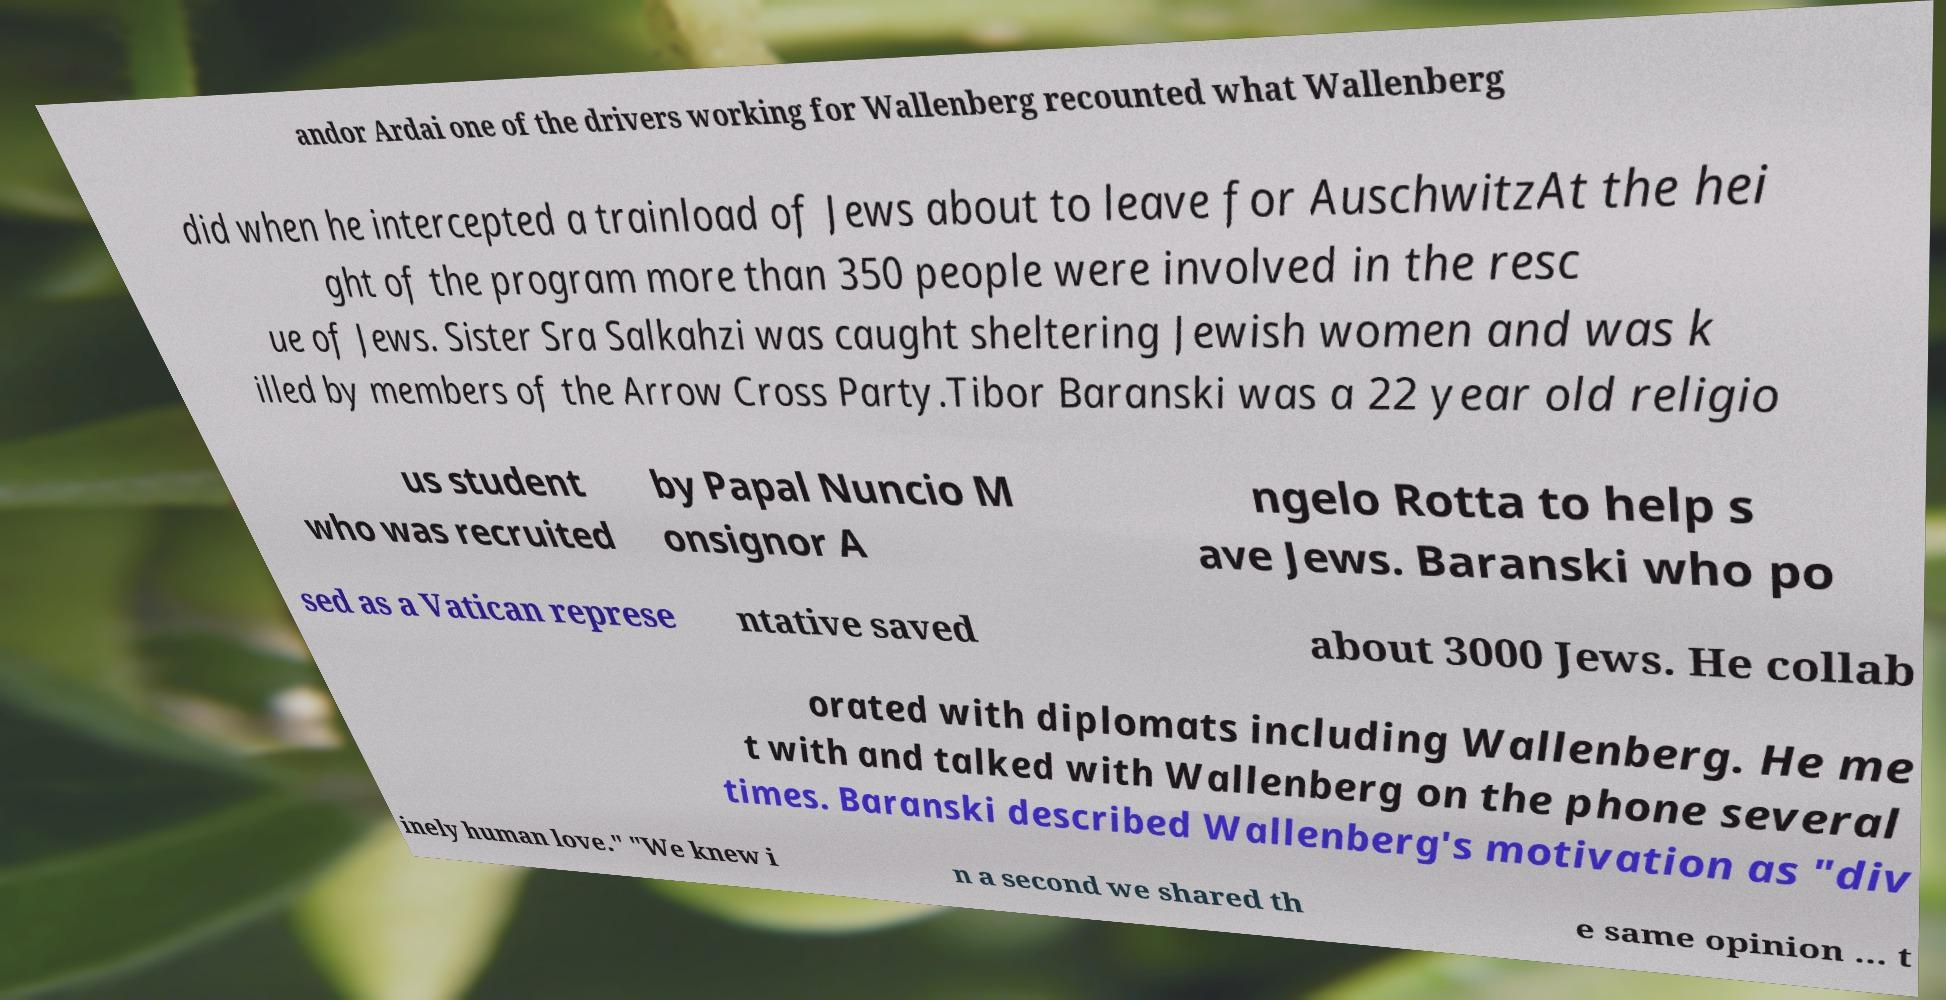For documentation purposes, I need the text within this image transcribed. Could you provide that? andor Ardai one of the drivers working for Wallenberg recounted what Wallenberg did when he intercepted a trainload of Jews about to leave for AuschwitzAt the hei ght of the program more than 350 people were involved in the resc ue of Jews. Sister Sra Salkahzi was caught sheltering Jewish women and was k illed by members of the Arrow Cross Party.Tibor Baranski was a 22 year old religio us student who was recruited by Papal Nuncio M onsignor A ngelo Rotta to help s ave Jews. Baranski who po sed as a Vatican represe ntative saved about 3000 Jews. He collab orated with diplomats including Wallenberg. He me t with and talked with Wallenberg on the phone several times. Baranski described Wallenberg's motivation as "div inely human love." "We knew i n a second we shared th e same opinion … t 